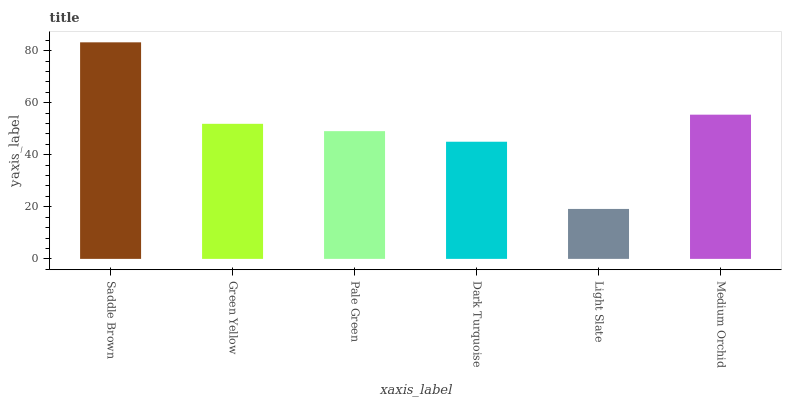Is Light Slate the minimum?
Answer yes or no. Yes. Is Saddle Brown the maximum?
Answer yes or no. Yes. Is Green Yellow the minimum?
Answer yes or no. No. Is Green Yellow the maximum?
Answer yes or no. No. Is Saddle Brown greater than Green Yellow?
Answer yes or no. Yes. Is Green Yellow less than Saddle Brown?
Answer yes or no. Yes. Is Green Yellow greater than Saddle Brown?
Answer yes or no. No. Is Saddle Brown less than Green Yellow?
Answer yes or no. No. Is Green Yellow the high median?
Answer yes or no. Yes. Is Pale Green the low median?
Answer yes or no. Yes. Is Pale Green the high median?
Answer yes or no. No. Is Light Slate the low median?
Answer yes or no. No. 